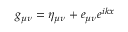Convert formula to latex. <formula><loc_0><loc_0><loc_500><loc_500>g _ { \mu \nu } = \eta _ { \mu \nu } + e _ { \mu \nu } e ^ { i k x }</formula> 